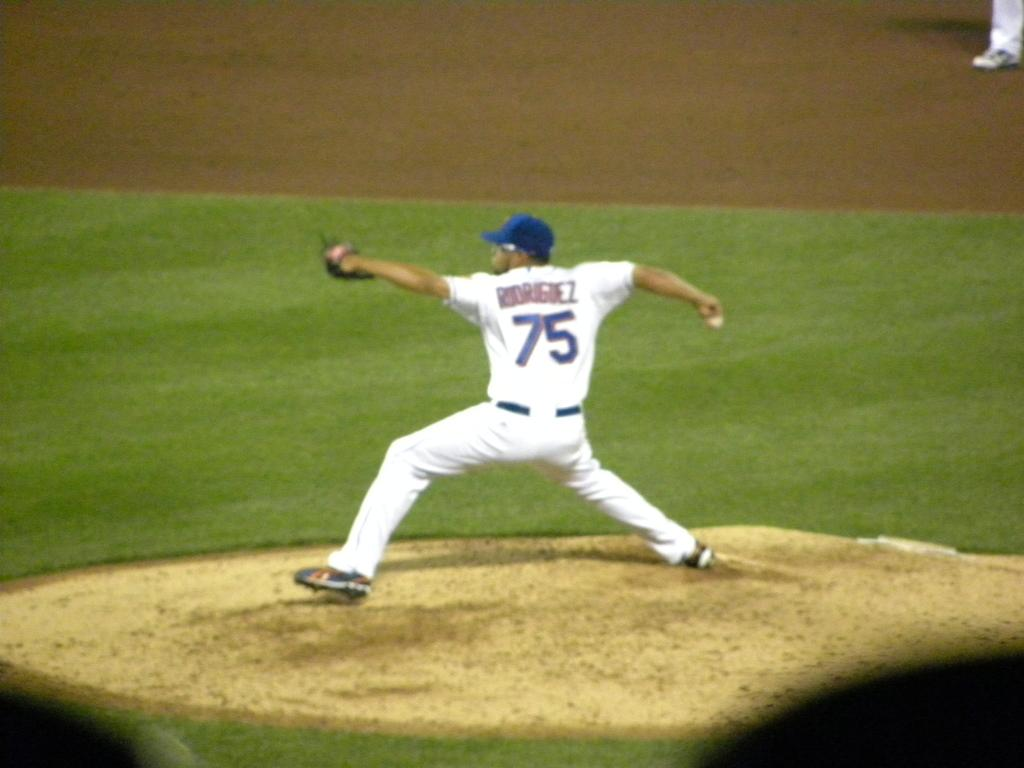<image>
Provide a brief description of the given image. Baseball player wearing number 75 pitching the baseball. 